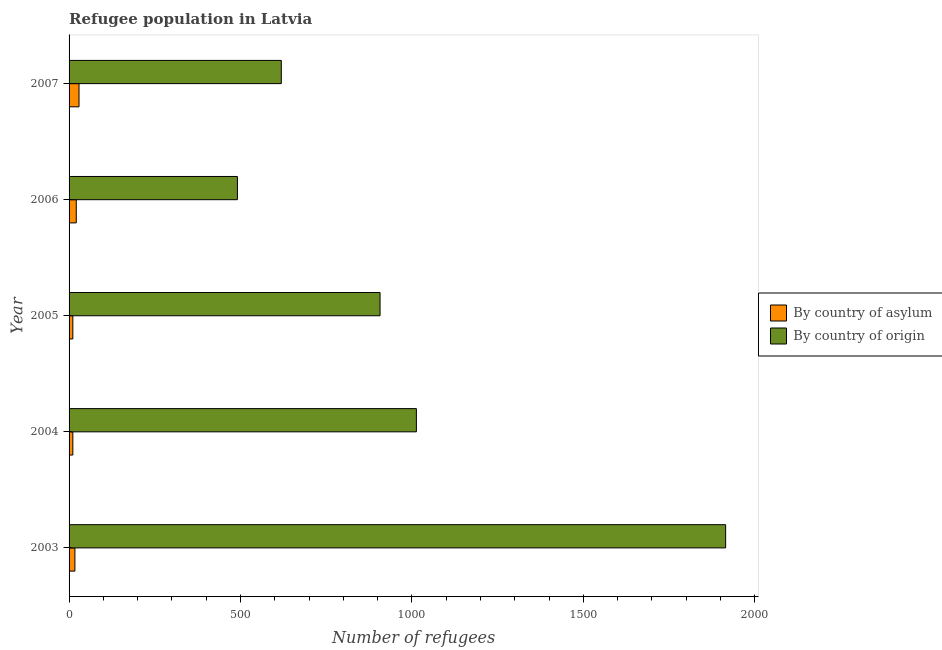How many different coloured bars are there?
Provide a succinct answer. 2. Are the number of bars per tick equal to the number of legend labels?
Give a very brief answer. Yes. Are the number of bars on each tick of the Y-axis equal?
Provide a short and direct response. Yes. How many bars are there on the 4th tick from the top?
Make the answer very short. 2. How many bars are there on the 1st tick from the bottom?
Make the answer very short. 2. What is the label of the 3rd group of bars from the top?
Make the answer very short. 2005. In how many cases, is the number of bars for a given year not equal to the number of legend labels?
Your response must be concise. 0. What is the number of refugees by country of origin in 2004?
Give a very brief answer. 1013. Across all years, what is the maximum number of refugees by country of origin?
Keep it short and to the point. 1915. Across all years, what is the minimum number of refugees by country of origin?
Give a very brief answer. 491. In which year was the number of refugees by country of asylum maximum?
Your answer should be compact. 2007. What is the total number of refugees by country of origin in the graph?
Ensure brevity in your answer.  4945. What is the difference between the number of refugees by country of origin in 2003 and that in 2007?
Make the answer very short. 1296. What is the difference between the number of refugees by country of origin in 2003 and the number of refugees by country of asylum in 2006?
Provide a succinct answer. 1894. What is the average number of refugees by country of origin per year?
Keep it short and to the point. 989. In the year 2004, what is the difference between the number of refugees by country of origin and number of refugees by country of asylum?
Your response must be concise. 1002. In how many years, is the number of refugees by country of origin greater than 700 ?
Your answer should be very brief. 3. What is the ratio of the number of refugees by country of asylum in 2005 to that in 2007?
Your answer should be compact. 0.38. Is the number of refugees by country of asylum in 2003 less than that in 2007?
Make the answer very short. Yes. What is the difference between the highest and the lowest number of refugees by country of origin?
Make the answer very short. 1424. Is the sum of the number of refugees by country of origin in 2003 and 2007 greater than the maximum number of refugees by country of asylum across all years?
Offer a terse response. Yes. What does the 2nd bar from the top in 2006 represents?
Make the answer very short. By country of asylum. What does the 2nd bar from the bottom in 2007 represents?
Offer a terse response. By country of origin. How many bars are there?
Your answer should be very brief. 10. Are all the bars in the graph horizontal?
Your answer should be compact. Yes. What is the difference between two consecutive major ticks on the X-axis?
Provide a short and direct response. 500. How many legend labels are there?
Your answer should be compact. 2. What is the title of the graph?
Offer a very short reply. Refugee population in Latvia. Does "Investments" appear as one of the legend labels in the graph?
Ensure brevity in your answer.  No. What is the label or title of the X-axis?
Give a very brief answer. Number of refugees. What is the Number of refugees in By country of asylum in 2003?
Make the answer very short. 17. What is the Number of refugees in By country of origin in 2003?
Your response must be concise. 1915. What is the Number of refugees of By country of asylum in 2004?
Make the answer very short. 11. What is the Number of refugees in By country of origin in 2004?
Ensure brevity in your answer.  1013. What is the Number of refugees of By country of origin in 2005?
Ensure brevity in your answer.  907. What is the Number of refugees of By country of asylum in 2006?
Ensure brevity in your answer.  21. What is the Number of refugees of By country of origin in 2006?
Provide a succinct answer. 491. What is the Number of refugees in By country of asylum in 2007?
Make the answer very short. 29. What is the Number of refugees of By country of origin in 2007?
Your answer should be compact. 619. Across all years, what is the maximum Number of refugees in By country of asylum?
Your answer should be very brief. 29. Across all years, what is the maximum Number of refugees in By country of origin?
Provide a succinct answer. 1915. Across all years, what is the minimum Number of refugees in By country of asylum?
Your answer should be very brief. 11. Across all years, what is the minimum Number of refugees of By country of origin?
Offer a very short reply. 491. What is the total Number of refugees of By country of asylum in the graph?
Keep it short and to the point. 89. What is the total Number of refugees of By country of origin in the graph?
Ensure brevity in your answer.  4945. What is the difference between the Number of refugees in By country of asylum in 2003 and that in 2004?
Ensure brevity in your answer.  6. What is the difference between the Number of refugees of By country of origin in 2003 and that in 2004?
Offer a terse response. 902. What is the difference between the Number of refugees in By country of origin in 2003 and that in 2005?
Make the answer very short. 1008. What is the difference between the Number of refugees of By country of origin in 2003 and that in 2006?
Offer a very short reply. 1424. What is the difference between the Number of refugees of By country of origin in 2003 and that in 2007?
Keep it short and to the point. 1296. What is the difference between the Number of refugees in By country of origin in 2004 and that in 2005?
Make the answer very short. 106. What is the difference between the Number of refugees of By country of asylum in 2004 and that in 2006?
Offer a very short reply. -10. What is the difference between the Number of refugees in By country of origin in 2004 and that in 2006?
Your response must be concise. 522. What is the difference between the Number of refugees in By country of asylum in 2004 and that in 2007?
Offer a terse response. -18. What is the difference between the Number of refugees of By country of origin in 2004 and that in 2007?
Offer a terse response. 394. What is the difference between the Number of refugees of By country of asylum in 2005 and that in 2006?
Make the answer very short. -10. What is the difference between the Number of refugees in By country of origin in 2005 and that in 2006?
Ensure brevity in your answer.  416. What is the difference between the Number of refugees of By country of origin in 2005 and that in 2007?
Give a very brief answer. 288. What is the difference between the Number of refugees of By country of origin in 2006 and that in 2007?
Make the answer very short. -128. What is the difference between the Number of refugees in By country of asylum in 2003 and the Number of refugees in By country of origin in 2004?
Keep it short and to the point. -996. What is the difference between the Number of refugees in By country of asylum in 2003 and the Number of refugees in By country of origin in 2005?
Your answer should be very brief. -890. What is the difference between the Number of refugees in By country of asylum in 2003 and the Number of refugees in By country of origin in 2006?
Provide a succinct answer. -474. What is the difference between the Number of refugees in By country of asylum in 2003 and the Number of refugees in By country of origin in 2007?
Provide a succinct answer. -602. What is the difference between the Number of refugees in By country of asylum in 2004 and the Number of refugees in By country of origin in 2005?
Your answer should be very brief. -896. What is the difference between the Number of refugees in By country of asylum in 2004 and the Number of refugees in By country of origin in 2006?
Your response must be concise. -480. What is the difference between the Number of refugees in By country of asylum in 2004 and the Number of refugees in By country of origin in 2007?
Your answer should be compact. -608. What is the difference between the Number of refugees of By country of asylum in 2005 and the Number of refugees of By country of origin in 2006?
Your response must be concise. -480. What is the difference between the Number of refugees in By country of asylum in 2005 and the Number of refugees in By country of origin in 2007?
Offer a very short reply. -608. What is the difference between the Number of refugees of By country of asylum in 2006 and the Number of refugees of By country of origin in 2007?
Your answer should be compact. -598. What is the average Number of refugees of By country of origin per year?
Provide a short and direct response. 989. In the year 2003, what is the difference between the Number of refugees of By country of asylum and Number of refugees of By country of origin?
Provide a short and direct response. -1898. In the year 2004, what is the difference between the Number of refugees in By country of asylum and Number of refugees in By country of origin?
Your answer should be very brief. -1002. In the year 2005, what is the difference between the Number of refugees in By country of asylum and Number of refugees in By country of origin?
Provide a succinct answer. -896. In the year 2006, what is the difference between the Number of refugees in By country of asylum and Number of refugees in By country of origin?
Provide a succinct answer. -470. In the year 2007, what is the difference between the Number of refugees in By country of asylum and Number of refugees in By country of origin?
Your answer should be very brief. -590. What is the ratio of the Number of refugees in By country of asylum in 2003 to that in 2004?
Ensure brevity in your answer.  1.55. What is the ratio of the Number of refugees of By country of origin in 2003 to that in 2004?
Make the answer very short. 1.89. What is the ratio of the Number of refugees in By country of asylum in 2003 to that in 2005?
Offer a very short reply. 1.55. What is the ratio of the Number of refugees of By country of origin in 2003 to that in 2005?
Your answer should be very brief. 2.11. What is the ratio of the Number of refugees of By country of asylum in 2003 to that in 2006?
Keep it short and to the point. 0.81. What is the ratio of the Number of refugees in By country of origin in 2003 to that in 2006?
Your answer should be very brief. 3.9. What is the ratio of the Number of refugees of By country of asylum in 2003 to that in 2007?
Provide a short and direct response. 0.59. What is the ratio of the Number of refugees in By country of origin in 2003 to that in 2007?
Your answer should be very brief. 3.09. What is the ratio of the Number of refugees of By country of origin in 2004 to that in 2005?
Your response must be concise. 1.12. What is the ratio of the Number of refugees of By country of asylum in 2004 to that in 2006?
Ensure brevity in your answer.  0.52. What is the ratio of the Number of refugees in By country of origin in 2004 to that in 2006?
Make the answer very short. 2.06. What is the ratio of the Number of refugees in By country of asylum in 2004 to that in 2007?
Your response must be concise. 0.38. What is the ratio of the Number of refugees in By country of origin in 2004 to that in 2007?
Make the answer very short. 1.64. What is the ratio of the Number of refugees in By country of asylum in 2005 to that in 2006?
Provide a short and direct response. 0.52. What is the ratio of the Number of refugees in By country of origin in 2005 to that in 2006?
Keep it short and to the point. 1.85. What is the ratio of the Number of refugees in By country of asylum in 2005 to that in 2007?
Ensure brevity in your answer.  0.38. What is the ratio of the Number of refugees of By country of origin in 2005 to that in 2007?
Offer a terse response. 1.47. What is the ratio of the Number of refugees in By country of asylum in 2006 to that in 2007?
Offer a terse response. 0.72. What is the ratio of the Number of refugees of By country of origin in 2006 to that in 2007?
Make the answer very short. 0.79. What is the difference between the highest and the second highest Number of refugees in By country of origin?
Give a very brief answer. 902. What is the difference between the highest and the lowest Number of refugees of By country of origin?
Provide a short and direct response. 1424. 